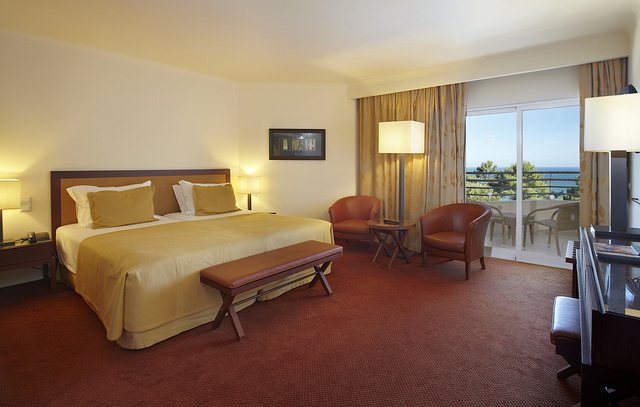Given the room layout, how would you rate its comfort for a vacation stay? The room appears quite comfortable for a vacation stay, offering ample lighting, a spacious bed with a cushioned headboard, cozy seating options, and a balcony to enjoy the view. It provides a balanced environment for both relaxation and leisure activities. 